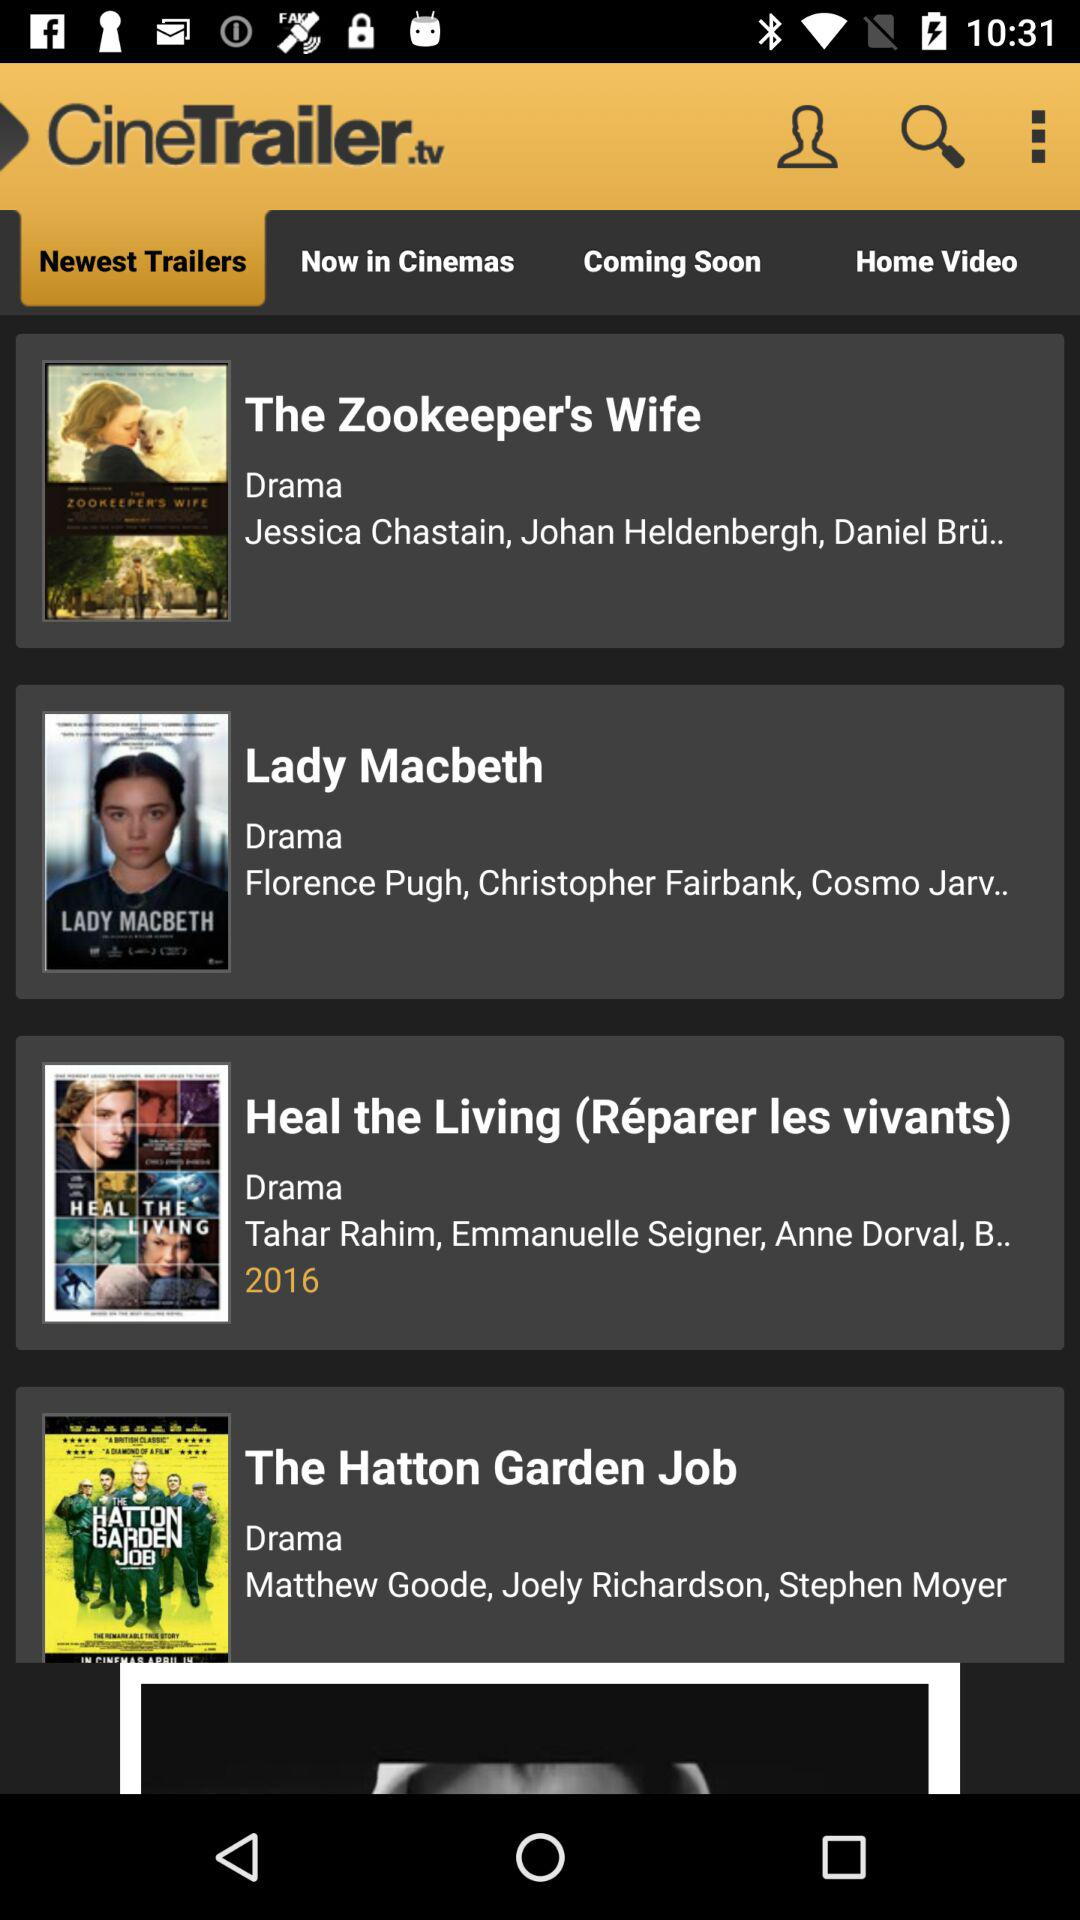Which is the selected tab? The selected tab is "Newest Trailers". 